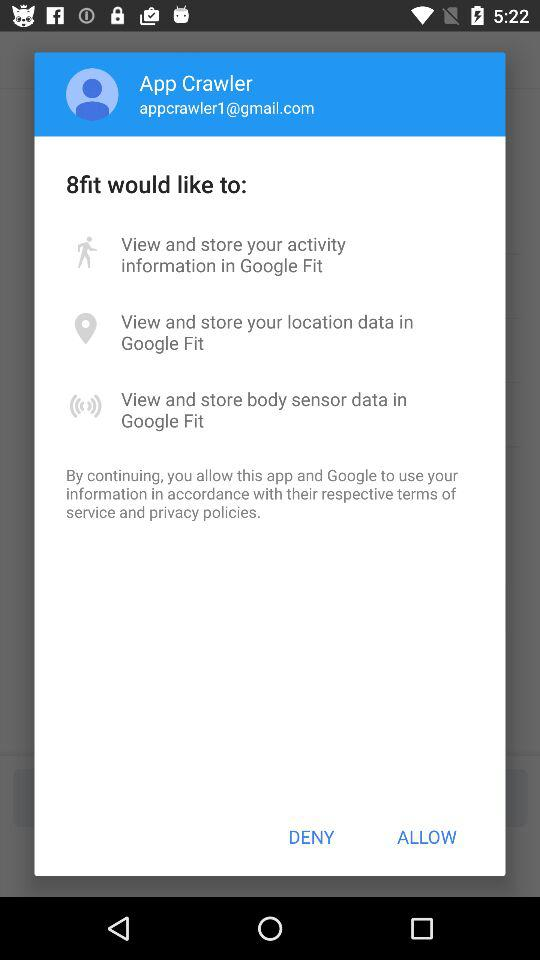How many permissions are requested?
Answer the question using a single word or phrase. 3 